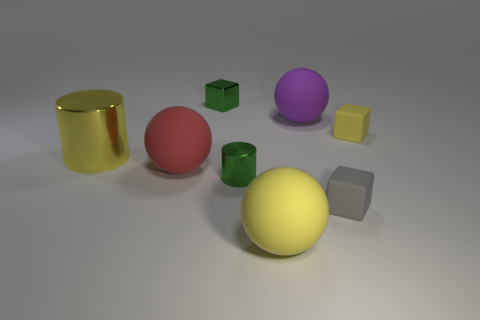Subtract all cylinders. How many objects are left? 6 Add 1 yellow cylinders. How many objects exist? 9 Subtract all red spheres. How many spheres are left? 2 Subtract all gray rubber blocks. How many blocks are left? 2 Subtract 1 yellow cylinders. How many objects are left? 7 Subtract 1 cylinders. How many cylinders are left? 1 Subtract all cyan spheres. Subtract all cyan cylinders. How many spheres are left? 3 Subtract all green cubes. How many cyan cylinders are left? 0 Subtract all large yellow balls. Subtract all big yellow metallic cylinders. How many objects are left? 6 Add 2 large objects. How many large objects are left? 6 